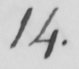Please provide the text content of this handwritten line. 14 . 